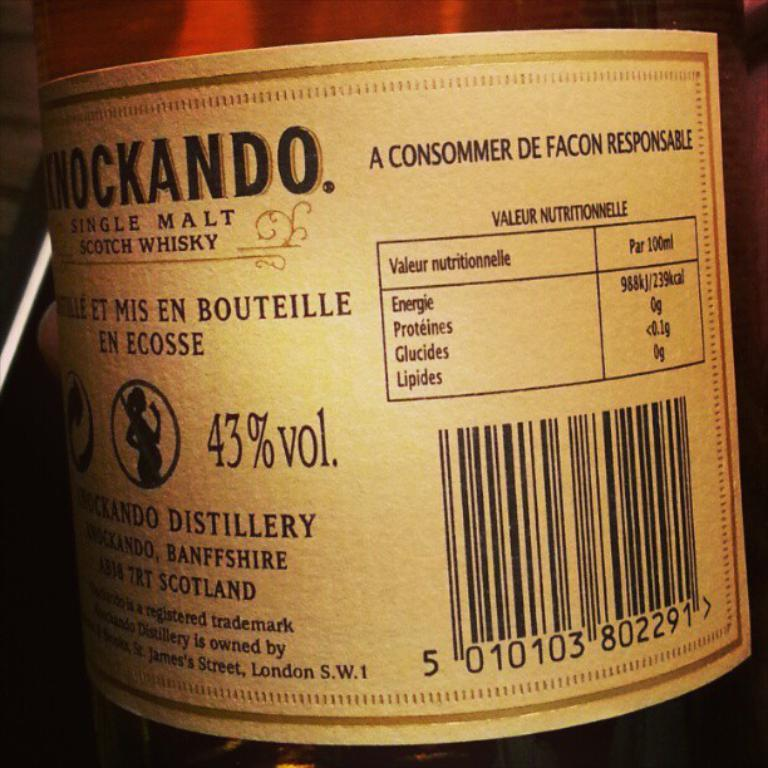<image>
Describe the image concisely. A brown bottle of alcohol is labeled as 43% volume. 